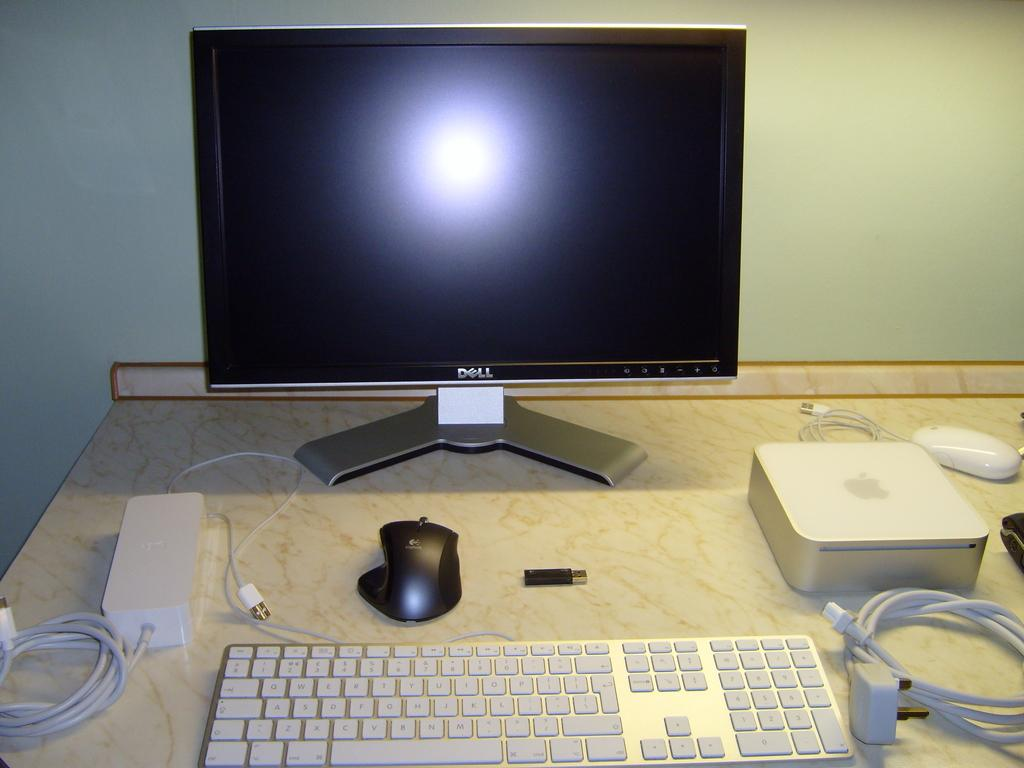Provide a one-sentence caption for the provided image. A keyboard, mouse and other computer devices sit on a desk before a blank Dell monitor. 